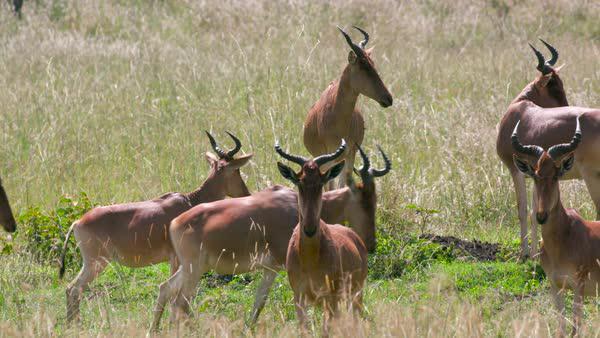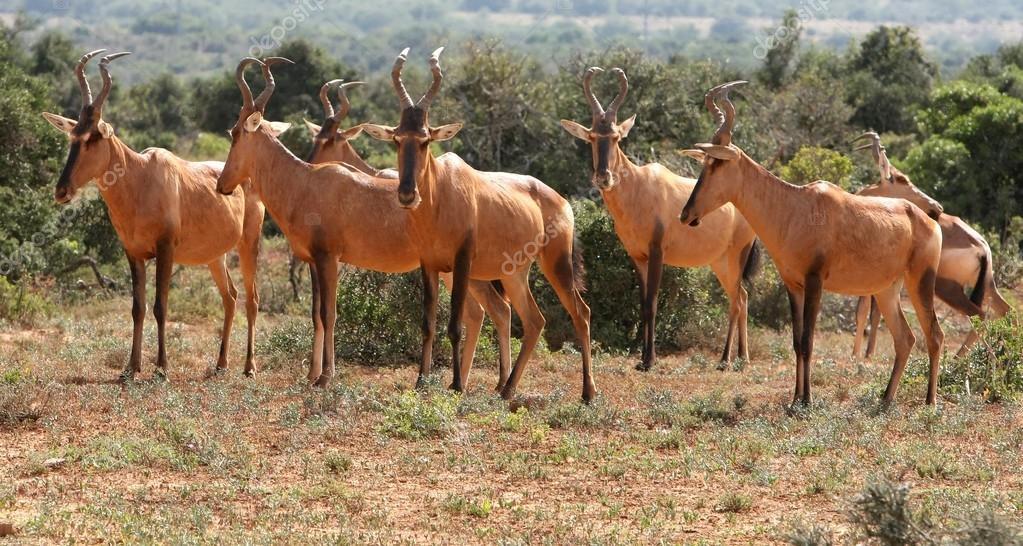The first image is the image on the left, the second image is the image on the right. Analyze the images presented: Is the assertion "The sky can not be seen in the image on the left." valid? Answer yes or no. Yes. 